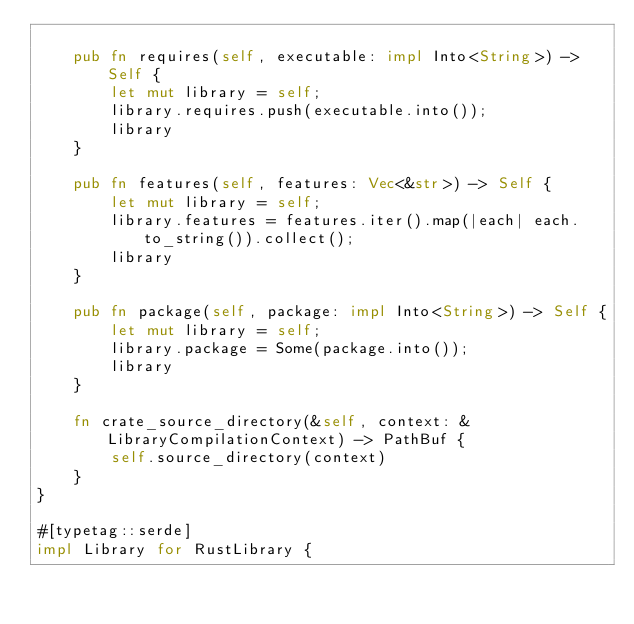<code> <loc_0><loc_0><loc_500><loc_500><_Rust_>
    pub fn requires(self, executable: impl Into<String>) -> Self {
        let mut library = self;
        library.requires.push(executable.into());
        library
    }

    pub fn features(self, features: Vec<&str>) -> Self {
        let mut library = self;
        library.features = features.iter().map(|each| each.to_string()).collect();
        library
    }

    pub fn package(self, package: impl Into<String>) -> Self {
        let mut library = self;
        library.package = Some(package.into());
        library
    }

    fn crate_source_directory(&self, context: &LibraryCompilationContext) -> PathBuf {
        self.source_directory(context)
    }
}

#[typetag::serde]
impl Library for RustLibrary {</code> 